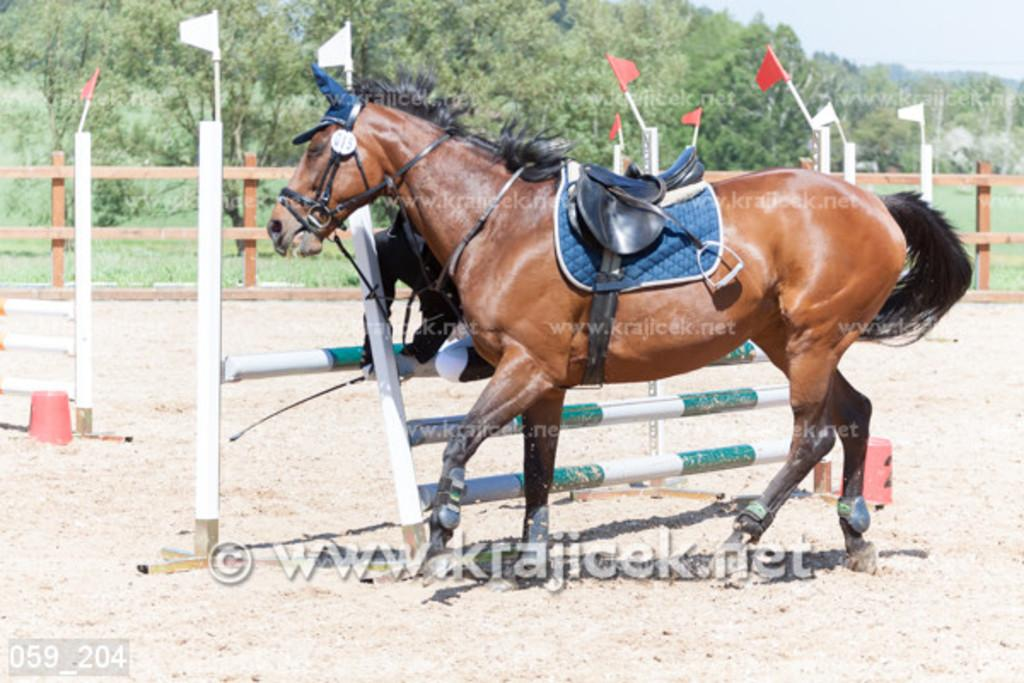What animal is present in the image? There is a horse in the image. What decorative elements can be seen in the image? There are flags in the image. What structures are present in the image? There are fences in the image. What type of natural scenery is visible in the image? There are trees at the back of the image. What type of crayon is the horse using to color in the image? There is no crayon present in the image, and horses do not use crayons. 